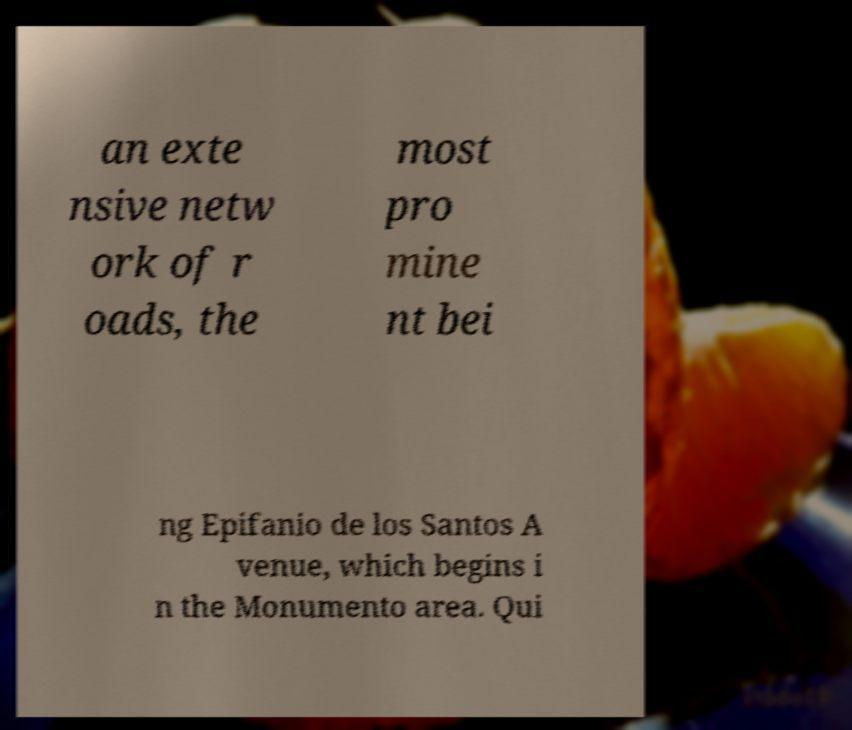Can you read and provide the text displayed in the image?This photo seems to have some interesting text. Can you extract and type it out for me? an exte nsive netw ork of r oads, the most pro mine nt bei ng Epifanio de los Santos A venue, which begins i n the Monumento area. Qui 